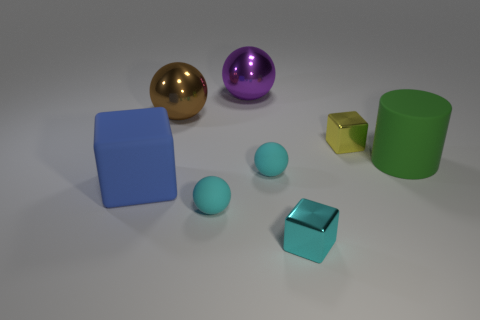Add 1 red rubber blocks. How many objects exist? 9 Subtract all blocks. How many objects are left? 5 Add 1 small cyan shiny cubes. How many small cyan shiny cubes are left? 2 Add 7 big red rubber cylinders. How many big red rubber cylinders exist? 7 Subtract 1 cyan cubes. How many objects are left? 7 Subtract all blue matte cylinders. Subtract all large green rubber cylinders. How many objects are left? 7 